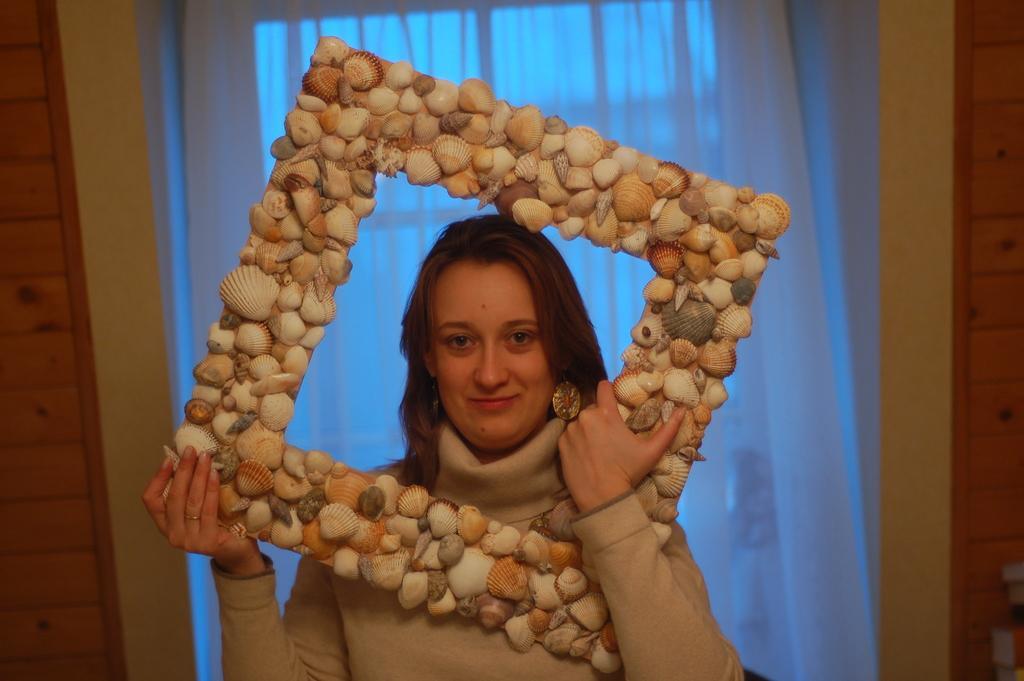Please provide a concise description of this image. In the image we can see a woman wearing clothes, finger ring, earring and she is smiling. She is holding an object which is square in shape. Here we can see the curtains and the wall. 